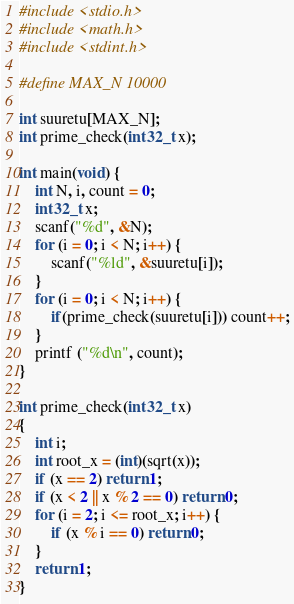Convert code to text. <code><loc_0><loc_0><loc_500><loc_500><_C_>#include <stdio.h>
#include <math.h>
#include <stdint.h>

#define MAX_N 10000

int suuretu[MAX_N];
int prime_check(int32_t x);

int main(void) {
    int N, i, count = 0;
    int32_t x;
    scanf("%d", &N);
    for (i = 0; i < N; i++) {
        scanf("%ld", &suuretu[i]);
    }
    for (i = 0; i < N; i++) {
        if(prime_check(suuretu[i])) count++;
    }
    printf ("%d\n", count);
}

int prime_check(int32_t x)
{
    int i;
    int root_x = (int)(sqrt(x));
    if (x == 2) return 1;
    if (x < 2 || x % 2 == 0) return 0;
    for (i = 2; i <= root_x; i++) {
        if (x % i == 0) return 0;
    }
    return 1;
}</code> 